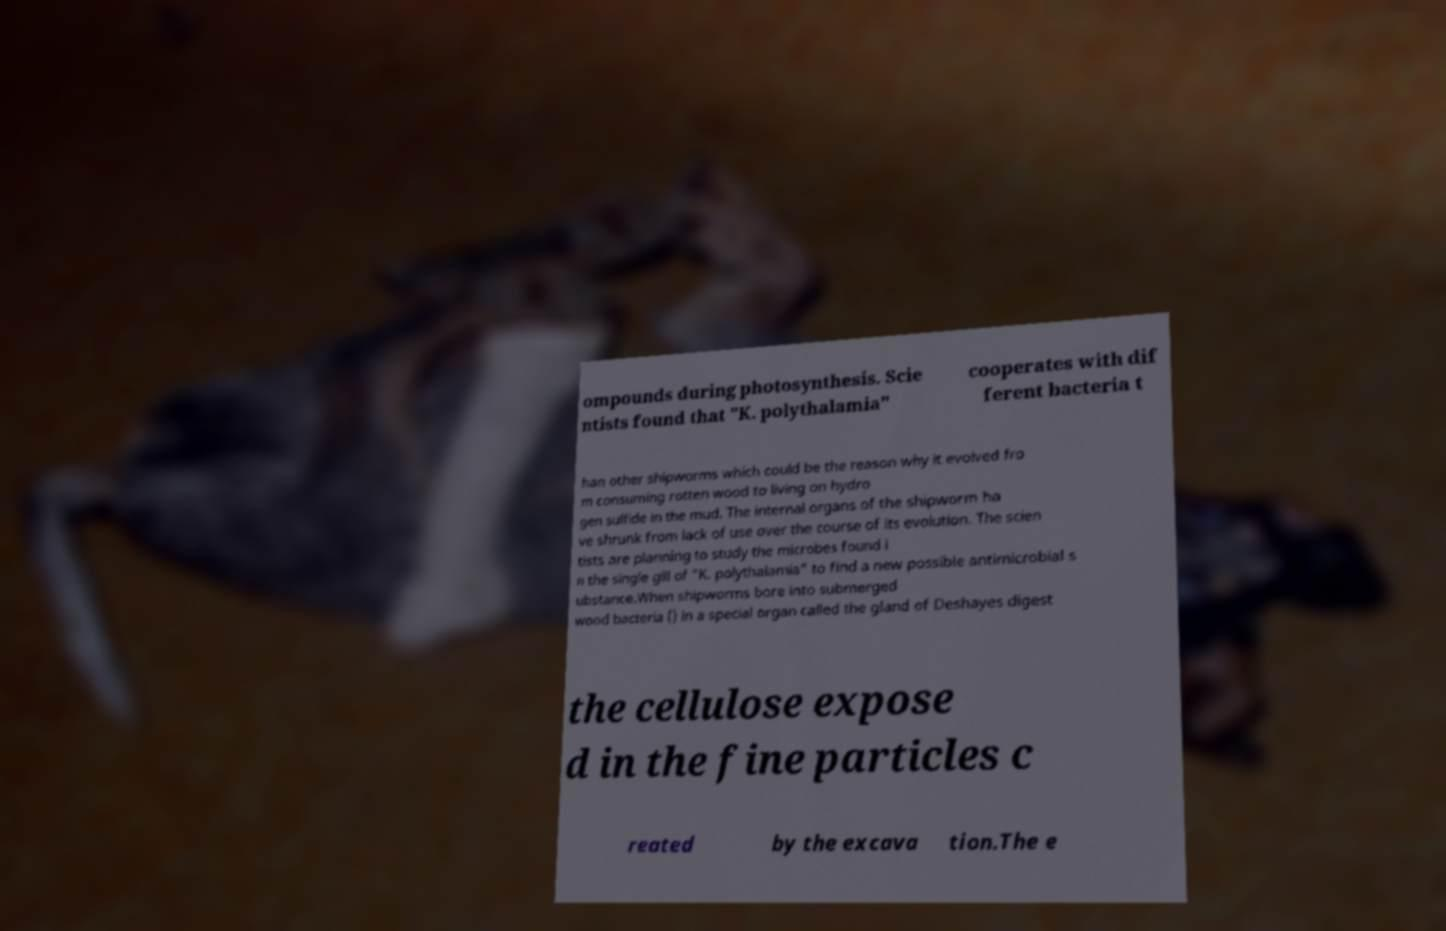For documentation purposes, I need the text within this image transcribed. Could you provide that? ompounds during photosynthesis. Scie ntists found that "K. polythalamia" cooperates with dif ferent bacteria t han other shipworms which could be the reason why it evolved fro m consuming rotten wood to living on hydro gen sulfide in the mud. The internal organs of the shipworm ha ve shrunk from lack of use over the course of its evolution. The scien tists are planning to study the microbes found i n the single gill of "K. polythalamia" to find a new possible antimicrobial s ubstance.When shipworms bore into submerged wood bacteria () in a special organ called the gland of Deshayes digest the cellulose expose d in the fine particles c reated by the excava tion.The e 